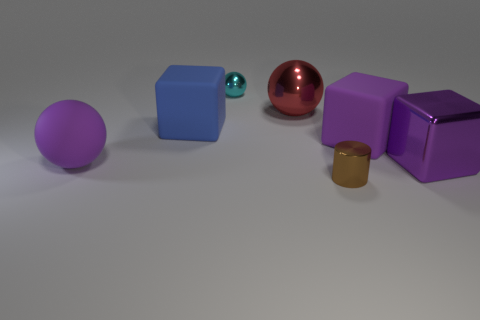Add 2 cyan things. How many objects exist? 9 Subtract all cylinders. How many objects are left? 6 Subtract 0 blue spheres. How many objects are left? 7 Subtract all brown metallic things. Subtract all blue metallic cubes. How many objects are left? 6 Add 2 small cyan shiny balls. How many small cyan shiny balls are left? 3 Add 5 big green metallic cubes. How many big green metallic cubes exist? 5 